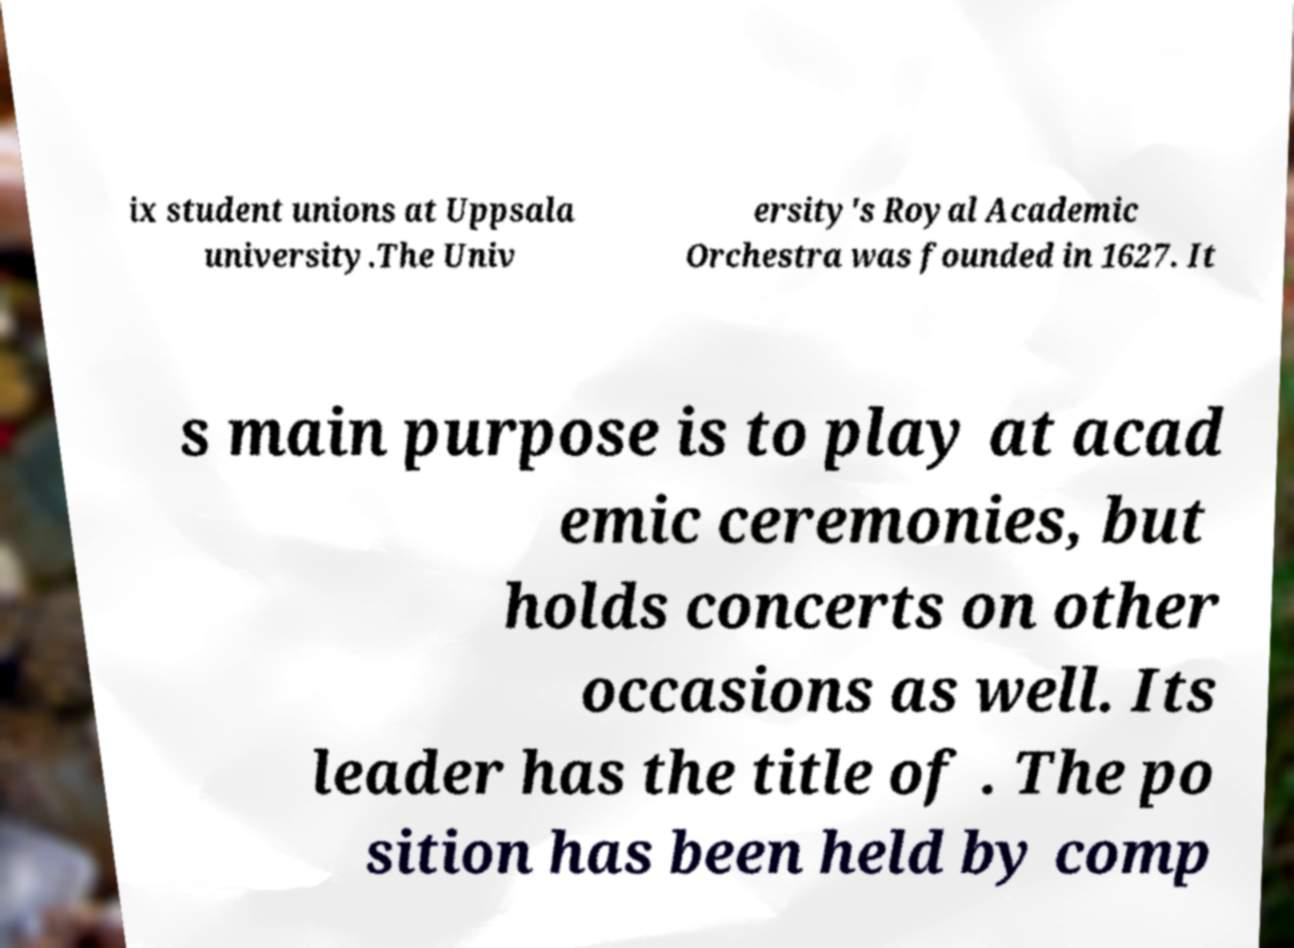There's text embedded in this image that I need extracted. Can you transcribe it verbatim? ix student unions at Uppsala university.The Univ ersity's Royal Academic Orchestra was founded in 1627. It s main purpose is to play at acad emic ceremonies, but holds concerts on other occasions as well. Its leader has the title of . The po sition has been held by comp 